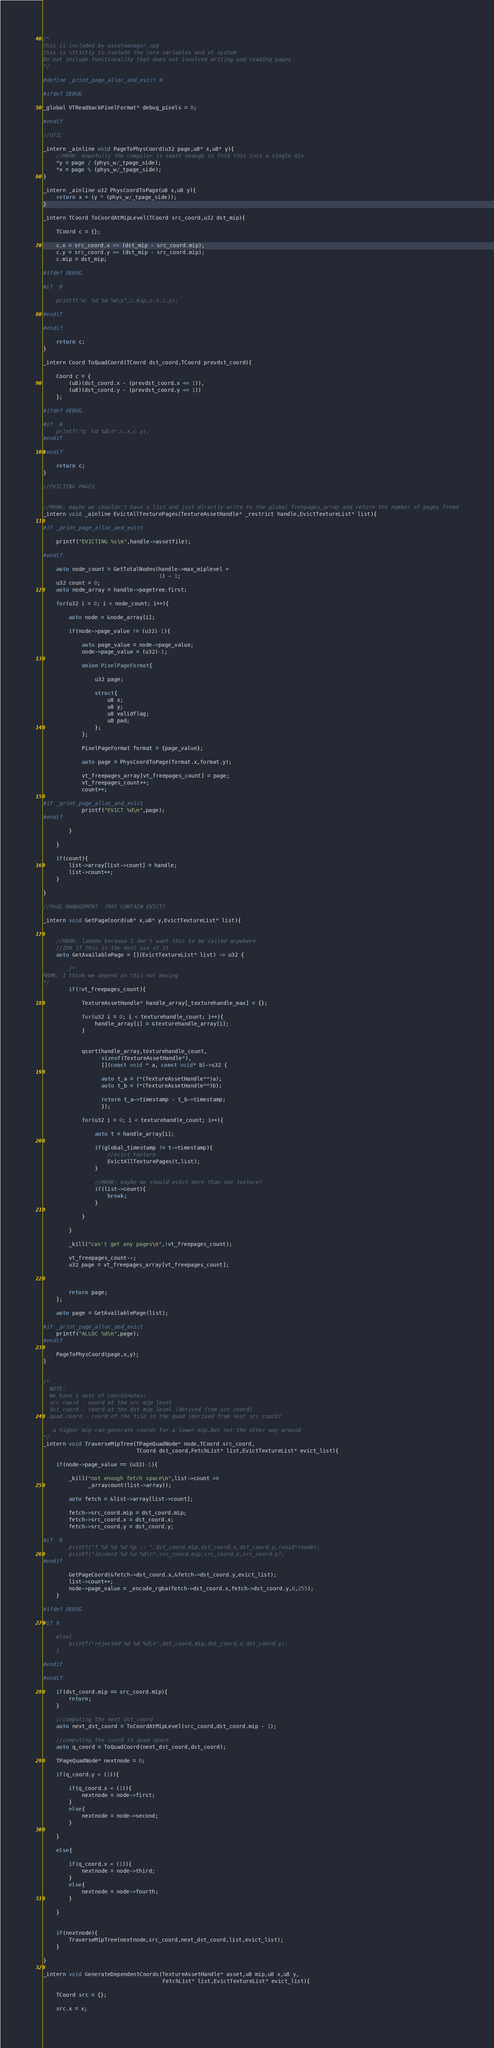<code> <loc_0><loc_0><loc_500><loc_500><_C++_>

/*
this is included by assetmanager.cpp
this is strictly to isolate the core variables and vt system 
Do not include functionality that does not involved writing and reading pages
*/

#define _print_page_alloc_and_evict 0

#ifdef DEBUG

_global VTReadbackPixelFormat* debug_pixels = 0;

#endif

//UTIL

_intern _ainline void PageToPhysCoord(u32 page,u8* x,u8* y){
    //MARK: Hopefully the compiler is smart enough to fold this into a single div
    *y = page / (phys_w/_tpage_side);
    *x = page % (phys_w/_tpage_side);
}

_intern _ainline u32 PhysCoordToPage(u8 x,u8 y){
    return x + (y * (phys_w/_tpage_side));
}

_intern TCoord ToCoordAtMipLevel(TCoord src_coord,u32 dst_mip){
    
    TCoord c = {};
    
    c.x = src_coord.x >> (dst_mip - src_coord.mip);
    c.y = src_coord.y >> (dst_mip - src_coord.mip);
    c.mip = dst_mip;
    
#ifdef DEBUG
    
#if  0
    
    printf("a: %d %d %d\n",c.mip,c.x,c.y);
    
#endif
    
#endif
    
    return c;
}

_intern Coord ToQuadCoord(TCoord dst_coord,TCoord prevdst_coord){
    
    Coord c = {
        (u8)(dst_coord.x - (prevdst_coord.x << 1)),
        (u8)(dst_coord.y - (prevdst_coord.y << 1))
    };
    
#ifdef DEBUG
    
#if  0
    printf("q: %d %d\n",c.x,c.y);
#endif
    
#endif
    
    return c;
}

//EVICTING PAGES


//MARK: maybe we shouldn't have a list and just directly write to the global freepages_array and return the number of pages freed
_intern void _ainline EvictAllTexturePages(TextureAssetHandle* _restrict handle,EvictTextureList* list){
    
#if _print_page_alloc_and_evict
    
    printf("EVICTING %s\n",handle->assetfile);
    
#endif
    
    auto node_count = GetTotalNodes(handle->max_miplevel +
                                    1) - 1;
    u32 count = 0;
    auto node_array = handle->pagetree.first;
    
    for(u32 i = 0; i < node_count; i++){
        
        auto node = &node_array[i];
        
        if(node->page_value != (u32)-1){
            
            auto page_value = node->page_value;
            node->page_value = (u32)-1;
            
            union PixelPageFormat{
                
                u32 page;
                
                struct{
                    u8 x;
                    u8 y;
                    u8 validflag;
                    u8 pad;
                };
            };
            
            PixelPageFormat format = {page_value};
            
            auto page = PhysCoordToPage(format.x,format.y);
            
            vt_freepages_array[vt_freepages_count] = page;
            vt_freepages_count++;
            count++;
            
#if _print_page_alloc_and_evict
            printf("EVICT %d\n",page);
#endif
            
        }
        
    }
    
    if(count){
        list->array[list->count] = handle;
        list->count++;
    }
    
}

//PAGE MANAGEMENT  (MAY CONTAIN EVICT)

_intern void GetPageCoord(u8* x,u8* y,EvictTextureList* list){
    
    
    //MARK: lambda becasue I don't want this to be called anywhere
    //IDK if this is the best use of it
    auto GetAvailablePage = [](EvictTextureList* list) -> u32 {
        
        /*
MARK: I think we depend on this not moving
*/
        if(!vt_freepages_count){
            
            TextureAssetHandle* handle_array[_texturehandle_max] = {};
            
            for(u32 i = 0; i < texturehandle_count; i++){
                handle_array[i] = &texturehandle_array[i];
            }
            
            
            qsort(handle_array,texturehandle_count,
                  sizeof(TextureAssetHandle*),
                  [](const void * a, const void* b)->s32 {
                  
                  auto t_a = (*(TextureAssetHandle**)a);
                  auto t_b = (*(TextureAssetHandle**)b);
                  
                  return t_a->timestamp - t_b->timestamp;
                  });
            
            for(u32 i = 0; i < texturehandle_count; i++){
                
                auto t = handle_array[i];
                
                if(global_timestamp != t->timestamp){
                    //evict texture
                    EvictAllTexturePages(t,list);
                }
                
                //MARK: maybe we should evict more than one texture?
                if(list->count){
                    break;
                }
                
            }
            
        }
        
        _kill("can't get any pages\n",!vt_freepages_count);
        
        vt_freepages_count--;
        u32 page = vt_freepages_array[vt_freepages_count];
        
        
        
        return page;
    };
    
    auto page = GetAvailablePage(list);
    
#if _print_page_alloc_and_evict
    printf("ALLOC %d\n",page);
#endif
    
    PageToPhysCoord(page,x,y);
}


/*
  NOTE: 
  We have 3 sets of coordinates:
  src coord - coord at the src mip level
  dst coord - coord at the dst mip level (derived from src coord)
  quad coord - coord of the tile in the quad (derived from next src coord)
  
   a higher mip can generate coords for a lower mip,but not the other way around
*/
_intern void TraverseMipTree(TPageQuadNode* node,TCoord src_coord,
                             TCoord dst_coord,FetchList* list,EvictTextureList* evict_list){
    
    if(node->page_value == (u32)-1){
        
        _kill("not enough fetch space\n",list->count >=
              _arraycount(list->array));
        
        auto fetch = &list->array[list->count];
        
        fetch->src_coord.mip = dst_coord.mip;
        fetch->src_coord.x = dst_coord.x;
        fetch->src_coord.y = dst_coord.y;
        
#if  0
        printf("f %d %d %d %p :: ",dst_coord.mip,dst_coord.x,dst_coord.y,(void*)node);
        printf("incoord %d %d %d\n",src_coord.mip,src_coord.x,src_coord.y);
#endif
        
        GetPageCoord(&fetch->dst_coord.x,&fetch->dst_coord.y,evict_list);
        list->count++;
        node->page_value = _encode_rgba(fetch->dst_coord.x,fetch->dst_coord.y,0,255);
    }
    
#ifdef DEBUG
    
#if 0
    
    else{
        printf("rejected %d %d %d\n",dst_coord.mip,dst_coord.x,dst_coord.y);
    }
    
#endif
    
#endif
    
    if(dst_coord.mip == src_coord.mip){
        return;
    }
    
    //computing the next dst_coord
    auto next_dst_coord = ToCoordAtMipLevel(src_coord,dst_coord.mip - 1);
    
    //computing the coord in quad space
    auto q_coord = ToQuadCoord(next_dst_coord,dst_coord);
    
    TPageQuadNode* nextnode = 0;
    
    if(q_coord.y < (1)){
        
        if(q_coord.x < (1)){
            nextnode = node->first;
        }
        else{
            nextnode = node->second;
        }
        
    }
    
    else{
        
        if(q_coord.x < (1)){
            nextnode = node->third;
        }
        else{
            nextnode = node->fourth;
        }
        
    }
    
    
    if(nextnode){
        TraverseMipTree(nextnode,src_coord,next_dst_coord,list,evict_list);
    }
    
}

_intern void GenerateDependentCoords(TextureAssetHandle* asset,u8 mip,u8 x,u8 y,
                                     FetchList* list,EvictTextureList* evict_list){
    
    TCoord src = {};
    
    src.x = x;</code> 